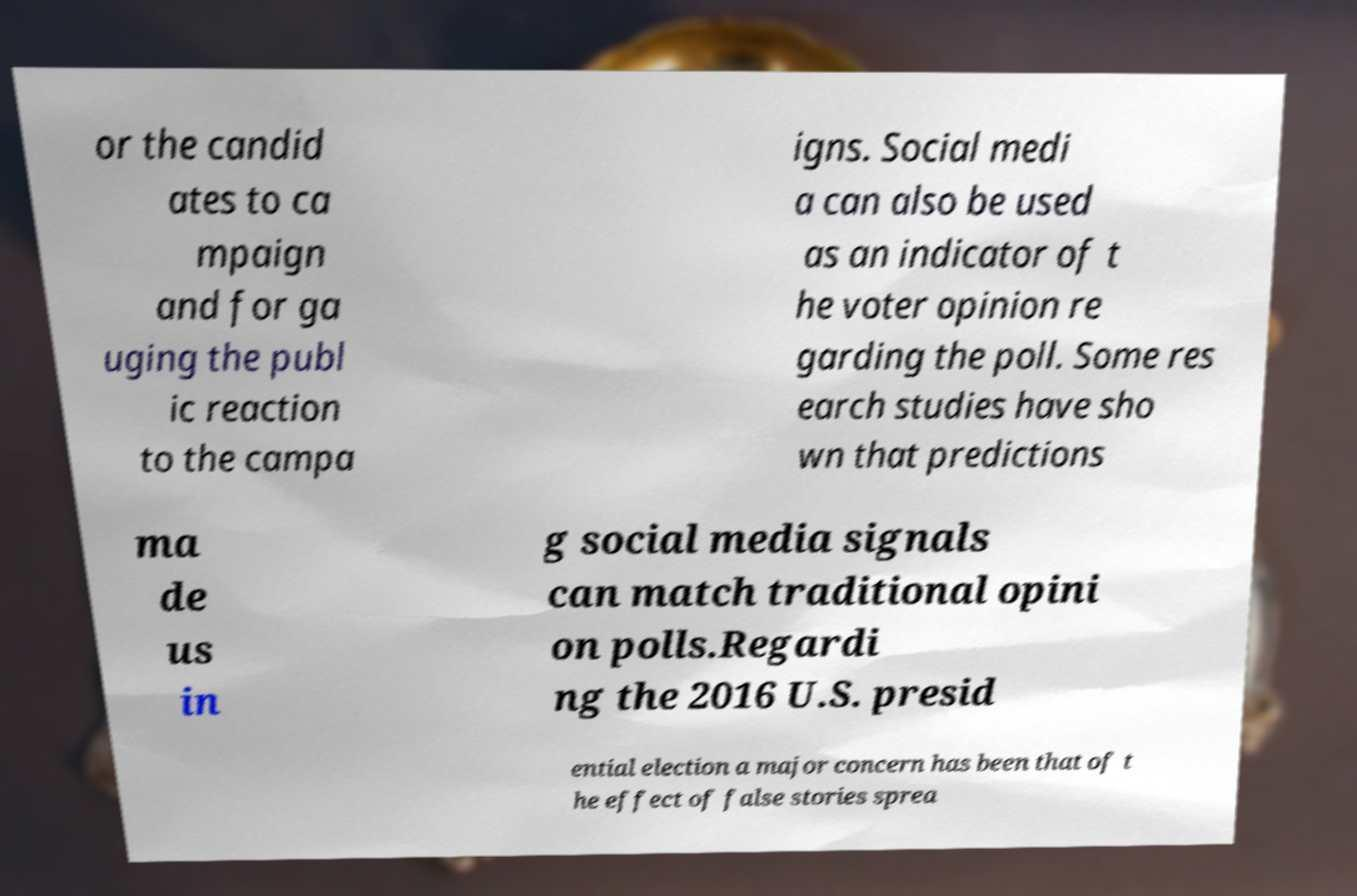What messages or text are displayed in this image? I need them in a readable, typed format. or the candid ates to ca mpaign and for ga uging the publ ic reaction to the campa igns. Social medi a can also be used as an indicator of t he voter opinion re garding the poll. Some res earch studies have sho wn that predictions ma de us in g social media signals can match traditional opini on polls.Regardi ng the 2016 U.S. presid ential election a major concern has been that of t he effect of false stories sprea 